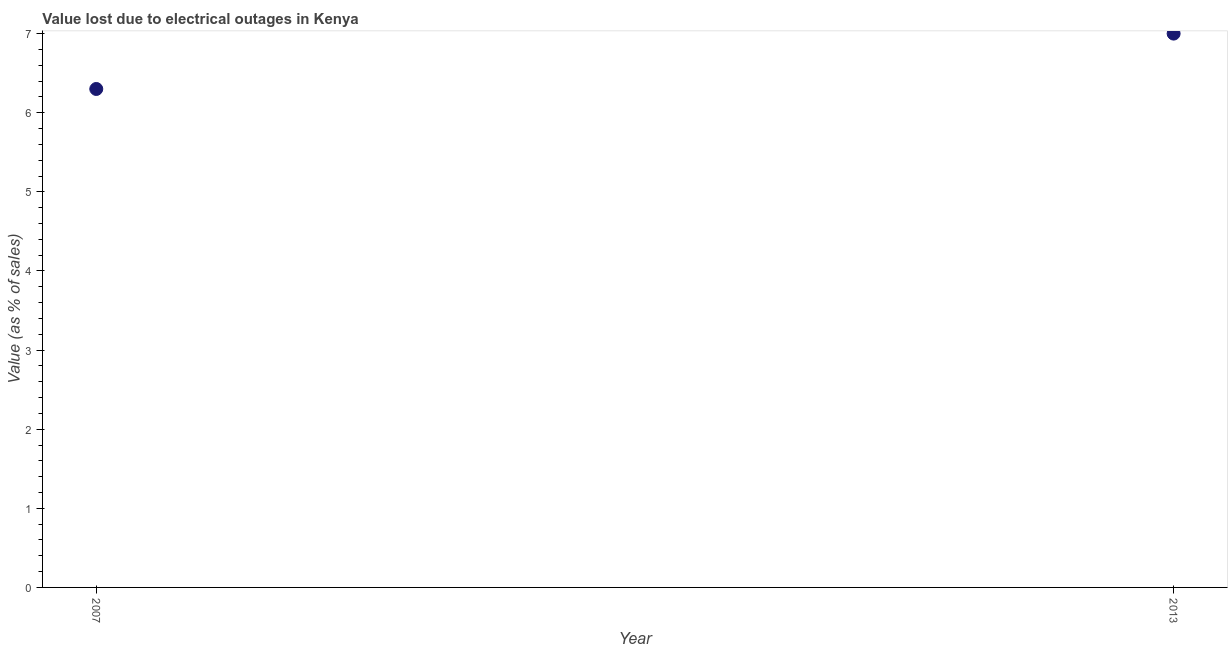What is the value lost due to electrical outages in 2007?
Your answer should be very brief. 6.3. Across all years, what is the maximum value lost due to electrical outages?
Provide a short and direct response. 7. In which year was the value lost due to electrical outages maximum?
Offer a very short reply. 2013. What is the difference between the value lost due to electrical outages in 2007 and 2013?
Offer a terse response. -0.7. What is the average value lost due to electrical outages per year?
Ensure brevity in your answer.  6.65. What is the median value lost due to electrical outages?
Ensure brevity in your answer.  6.65. In how many years, is the value lost due to electrical outages greater than 0.8 %?
Your answer should be compact. 2. Do a majority of the years between 2013 and 2007 (inclusive) have value lost due to electrical outages greater than 5.2 %?
Make the answer very short. No. What is the ratio of the value lost due to electrical outages in 2007 to that in 2013?
Keep it short and to the point. 0.9. In how many years, is the value lost due to electrical outages greater than the average value lost due to electrical outages taken over all years?
Make the answer very short. 1. Does the value lost due to electrical outages monotonically increase over the years?
Provide a succinct answer. Yes. How many dotlines are there?
Your answer should be compact. 1. How many years are there in the graph?
Provide a short and direct response. 2. What is the difference between two consecutive major ticks on the Y-axis?
Offer a terse response. 1. Are the values on the major ticks of Y-axis written in scientific E-notation?
Your answer should be very brief. No. Does the graph contain any zero values?
Offer a terse response. No. Does the graph contain grids?
Your answer should be very brief. No. What is the title of the graph?
Ensure brevity in your answer.  Value lost due to electrical outages in Kenya. What is the label or title of the Y-axis?
Your answer should be compact. Value (as % of sales). What is the Value (as % of sales) in 2007?
Keep it short and to the point. 6.3. What is the difference between the Value (as % of sales) in 2007 and 2013?
Keep it short and to the point. -0.7. What is the ratio of the Value (as % of sales) in 2007 to that in 2013?
Provide a short and direct response. 0.9. 